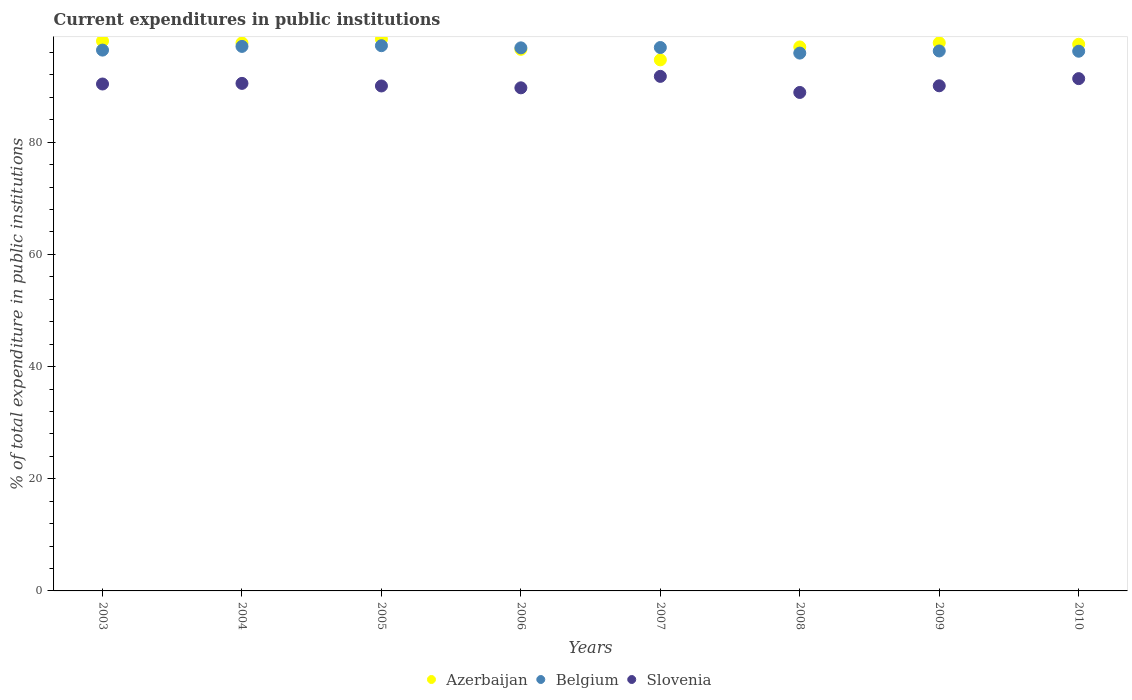Is the number of dotlines equal to the number of legend labels?
Keep it short and to the point. Yes. What is the current expenditures in public institutions in Belgium in 2006?
Provide a succinct answer. 96.82. Across all years, what is the maximum current expenditures in public institutions in Belgium?
Provide a short and direct response. 97.21. Across all years, what is the minimum current expenditures in public institutions in Azerbaijan?
Provide a succinct answer. 94.68. In which year was the current expenditures in public institutions in Azerbaijan maximum?
Offer a terse response. 2005. What is the total current expenditures in public institutions in Belgium in the graph?
Provide a short and direct response. 772.79. What is the difference between the current expenditures in public institutions in Azerbaijan in 2004 and that in 2009?
Make the answer very short. -0.02. What is the difference between the current expenditures in public institutions in Azerbaijan in 2003 and the current expenditures in public institutions in Belgium in 2008?
Your answer should be compact. 2.14. What is the average current expenditures in public institutions in Azerbaijan per year?
Provide a short and direct response. 97.19. In the year 2007, what is the difference between the current expenditures in public institutions in Slovenia and current expenditures in public institutions in Belgium?
Provide a short and direct response. -5.14. What is the ratio of the current expenditures in public institutions in Azerbaijan in 2006 to that in 2010?
Offer a terse response. 0.99. Is the current expenditures in public institutions in Belgium in 2009 less than that in 2010?
Ensure brevity in your answer.  No. Is the difference between the current expenditures in public institutions in Slovenia in 2003 and 2005 greater than the difference between the current expenditures in public institutions in Belgium in 2003 and 2005?
Provide a succinct answer. Yes. What is the difference between the highest and the second highest current expenditures in public institutions in Belgium?
Your answer should be very brief. 0.13. What is the difference between the highest and the lowest current expenditures in public institutions in Slovenia?
Give a very brief answer. 2.87. In how many years, is the current expenditures in public institutions in Belgium greater than the average current expenditures in public institutions in Belgium taken over all years?
Offer a very short reply. 4. Is it the case that in every year, the sum of the current expenditures in public institutions in Slovenia and current expenditures in public institutions in Belgium  is greater than the current expenditures in public institutions in Azerbaijan?
Offer a very short reply. Yes. Does the current expenditures in public institutions in Azerbaijan monotonically increase over the years?
Provide a short and direct response. No. Is the current expenditures in public institutions in Belgium strictly greater than the current expenditures in public institutions in Slovenia over the years?
Provide a short and direct response. Yes. What is the difference between two consecutive major ticks on the Y-axis?
Your answer should be compact. 20. Are the values on the major ticks of Y-axis written in scientific E-notation?
Your response must be concise. No. Where does the legend appear in the graph?
Make the answer very short. Bottom center. How are the legend labels stacked?
Ensure brevity in your answer.  Horizontal. What is the title of the graph?
Give a very brief answer. Current expenditures in public institutions. Does "Paraguay" appear as one of the legend labels in the graph?
Make the answer very short. No. What is the label or title of the Y-axis?
Your answer should be very brief. % of total expenditure in public institutions. What is the % of total expenditure in public institutions in Azerbaijan in 2003?
Give a very brief answer. 98.03. What is the % of total expenditure in public institutions of Belgium in 2003?
Offer a terse response. 96.42. What is the % of total expenditure in public institutions in Slovenia in 2003?
Your response must be concise. 90.38. What is the % of total expenditure in public institutions in Azerbaijan in 2004?
Offer a very short reply. 97.7. What is the % of total expenditure in public institutions of Belgium in 2004?
Provide a short and direct response. 97.08. What is the % of total expenditure in public institutions in Slovenia in 2004?
Ensure brevity in your answer.  90.49. What is the % of total expenditure in public institutions in Azerbaijan in 2005?
Offer a terse response. 98.36. What is the % of total expenditure in public institutions of Belgium in 2005?
Make the answer very short. 97.21. What is the % of total expenditure in public institutions of Slovenia in 2005?
Ensure brevity in your answer.  90.03. What is the % of total expenditure in public institutions in Azerbaijan in 2006?
Provide a short and direct response. 96.56. What is the % of total expenditure in public institutions of Belgium in 2006?
Your answer should be compact. 96.82. What is the % of total expenditure in public institutions of Slovenia in 2006?
Make the answer very short. 89.7. What is the % of total expenditure in public institutions of Azerbaijan in 2007?
Your answer should be compact. 94.68. What is the % of total expenditure in public institutions in Belgium in 2007?
Ensure brevity in your answer.  96.88. What is the % of total expenditure in public institutions of Slovenia in 2007?
Your answer should be very brief. 91.74. What is the % of total expenditure in public institutions in Azerbaijan in 2008?
Give a very brief answer. 96.99. What is the % of total expenditure in public institutions of Belgium in 2008?
Your answer should be very brief. 95.89. What is the % of total expenditure in public institutions of Slovenia in 2008?
Your answer should be compact. 88.87. What is the % of total expenditure in public institutions in Azerbaijan in 2009?
Your answer should be compact. 97.72. What is the % of total expenditure in public institutions in Belgium in 2009?
Give a very brief answer. 96.27. What is the % of total expenditure in public institutions in Slovenia in 2009?
Make the answer very short. 90.06. What is the % of total expenditure in public institutions of Azerbaijan in 2010?
Keep it short and to the point. 97.46. What is the % of total expenditure in public institutions of Belgium in 2010?
Offer a very short reply. 96.22. What is the % of total expenditure in public institutions of Slovenia in 2010?
Your answer should be very brief. 91.34. Across all years, what is the maximum % of total expenditure in public institutions in Azerbaijan?
Keep it short and to the point. 98.36. Across all years, what is the maximum % of total expenditure in public institutions of Belgium?
Offer a terse response. 97.21. Across all years, what is the maximum % of total expenditure in public institutions in Slovenia?
Offer a very short reply. 91.74. Across all years, what is the minimum % of total expenditure in public institutions of Azerbaijan?
Keep it short and to the point. 94.68. Across all years, what is the minimum % of total expenditure in public institutions of Belgium?
Offer a very short reply. 95.89. Across all years, what is the minimum % of total expenditure in public institutions in Slovenia?
Your answer should be compact. 88.87. What is the total % of total expenditure in public institutions of Azerbaijan in the graph?
Your response must be concise. 777.49. What is the total % of total expenditure in public institutions of Belgium in the graph?
Make the answer very short. 772.79. What is the total % of total expenditure in public institutions of Slovenia in the graph?
Offer a terse response. 722.6. What is the difference between the % of total expenditure in public institutions in Azerbaijan in 2003 and that in 2004?
Your answer should be very brief. 0.34. What is the difference between the % of total expenditure in public institutions of Belgium in 2003 and that in 2004?
Make the answer very short. -0.66. What is the difference between the % of total expenditure in public institutions of Slovenia in 2003 and that in 2004?
Ensure brevity in your answer.  -0.11. What is the difference between the % of total expenditure in public institutions in Azerbaijan in 2003 and that in 2005?
Ensure brevity in your answer.  -0.33. What is the difference between the % of total expenditure in public institutions of Belgium in 2003 and that in 2005?
Provide a short and direct response. -0.79. What is the difference between the % of total expenditure in public institutions of Slovenia in 2003 and that in 2005?
Ensure brevity in your answer.  0.35. What is the difference between the % of total expenditure in public institutions of Azerbaijan in 2003 and that in 2006?
Keep it short and to the point. 1.47. What is the difference between the % of total expenditure in public institutions of Belgium in 2003 and that in 2006?
Your answer should be very brief. -0.4. What is the difference between the % of total expenditure in public institutions of Slovenia in 2003 and that in 2006?
Ensure brevity in your answer.  0.68. What is the difference between the % of total expenditure in public institutions in Azerbaijan in 2003 and that in 2007?
Your response must be concise. 3.35. What is the difference between the % of total expenditure in public institutions of Belgium in 2003 and that in 2007?
Ensure brevity in your answer.  -0.46. What is the difference between the % of total expenditure in public institutions in Slovenia in 2003 and that in 2007?
Offer a terse response. -1.36. What is the difference between the % of total expenditure in public institutions of Azerbaijan in 2003 and that in 2008?
Offer a terse response. 1.05. What is the difference between the % of total expenditure in public institutions in Belgium in 2003 and that in 2008?
Your answer should be compact. 0.53. What is the difference between the % of total expenditure in public institutions of Slovenia in 2003 and that in 2008?
Your response must be concise. 1.51. What is the difference between the % of total expenditure in public institutions in Azerbaijan in 2003 and that in 2009?
Your answer should be very brief. 0.32. What is the difference between the % of total expenditure in public institutions in Belgium in 2003 and that in 2009?
Give a very brief answer. 0.15. What is the difference between the % of total expenditure in public institutions of Slovenia in 2003 and that in 2009?
Provide a short and direct response. 0.32. What is the difference between the % of total expenditure in public institutions of Azerbaijan in 2003 and that in 2010?
Provide a succinct answer. 0.57. What is the difference between the % of total expenditure in public institutions in Belgium in 2003 and that in 2010?
Your response must be concise. 0.2. What is the difference between the % of total expenditure in public institutions in Slovenia in 2003 and that in 2010?
Ensure brevity in your answer.  -0.96. What is the difference between the % of total expenditure in public institutions in Azerbaijan in 2004 and that in 2005?
Ensure brevity in your answer.  -0.66. What is the difference between the % of total expenditure in public institutions in Belgium in 2004 and that in 2005?
Make the answer very short. -0.13. What is the difference between the % of total expenditure in public institutions of Slovenia in 2004 and that in 2005?
Offer a very short reply. 0.46. What is the difference between the % of total expenditure in public institutions of Azerbaijan in 2004 and that in 2006?
Provide a short and direct response. 1.14. What is the difference between the % of total expenditure in public institutions in Belgium in 2004 and that in 2006?
Keep it short and to the point. 0.26. What is the difference between the % of total expenditure in public institutions in Slovenia in 2004 and that in 2006?
Ensure brevity in your answer.  0.79. What is the difference between the % of total expenditure in public institutions in Azerbaijan in 2004 and that in 2007?
Provide a succinct answer. 3.02. What is the difference between the % of total expenditure in public institutions in Belgium in 2004 and that in 2007?
Your response must be concise. 0.2. What is the difference between the % of total expenditure in public institutions of Slovenia in 2004 and that in 2007?
Make the answer very short. -1.25. What is the difference between the % of total expenditure in public institutions of Azerbaijan in 2004 and that in 2008?
Keep it short and to the point. 0.71. What is the difference between the % of total expenditure in public institutions of Belgium in 2004 and that in 2008?
Your response must be concise. 1.19. What is the difference between the % of total expenditure in public institutions in Slovenia in 2004 and that in 2008?
Make the answer very short. 1.62. What is the difference between the % of total expenditure in public institutions of Azerbaijan in 2004 and that in 2009?
Give a very brief answer. -0.02. What is the difference between the % of total expenditure in public institutions of Belgium in 2004 and that in 2009?
Offer a very short reply. 0.81. What is the difference between the % of total expenditure in public institutions of Slovenia in 2004 and that in 2009?
Make the answer very short. 0.43. What is the difference between the % of total expenditure in public institutions of Azerbaijan in 2004 and that in 2010?
Offer a terse response. 0.23. What is the difference between the % of total expenditure in public institutions in Belgium in 2004 and that in 2010?
Keep it short and to the point. 0.86. What is the difference between the % of total expenditure in public institutions in Slovenia in 2004 and that in 2010?
Keep it short and to the point. -0.85. What is the difference between the % of total expenditure in public institutions in Azerbaijan in 2005 and that in 2006?
Offer a terse response. 1.8. What is the difference between the % of total expenditure in public institutions in Belgium in 2005 and that in 2006?
Ensure brevity in your answer.  0.39. What is the difference between the % of total expenditure in public institutions of Slovenia in 2005 and that in 2006?
Provide a succinct answer. 0.33. What is the difference between the % of total expenditure in public institutions in Azerbaijan in 2005 and that in 2007?
Offer a terse response. 3.68. What is the difference between the % of total expenditure in public institutions in Belgium in 2005 and that in 2007?
Your response must be concise. 0.33. What is the difference between the % of total expenditure in public institutions in Slovenia in 2005 and that in 2007?
Ensure brevity in your answer.  -1.71. What is the difference between the % of total expenditure in public institutions in Azerbaijan in 2005 and that in 2008?
Provide a short and direct response. 1.37. What is the difference between the % of total expenditure in public institutions in Belgium in 2005 and that in 2008?
Offer a very short reply. 1.32. What is the difference between the % of total expenditure in public institutions in Slovenia in 2005 and that in 2008?
Ensure brevity in your answer.  1.16. What is the difference between the % of total expenditure in public institutions of Azerbaijan in 2005 and that in 2009?
Your answer should be very brief. 0.64. What is the difference between the % of total expenditure in public institutions of Belgium in 2005 and that in 2009?
Offer a very short reply. 0.94. What is the difference between the % of total expenditure in public institutions in Slovenia in 2005 and that in 2009?
Your answer should be compact. -0.03. What is the difference between the % of total expenditure in public institutions in Azerbaijan in 2005 and that in 2010?
Give a very brief answer. 0.9. What is the difference between the % of total expenditure in public institutions of Belgium in 2005 and that in 2010?
Offer a very short reply. 0.98. What is the difference between the % of total expenditure in public institutions of Slovenia in 2005 and that in 2010?
Give a very brief answer. -1.31. What is the difference between the % of total expenditure in public institutions in Azerbaijan in 2006 and that in 2007?
Your response must be concise. 1.88. What is the difference between the % of total expenditure in public institutions in Belgium in 2006 and that in 2007?
Give a very brief answer. -0.06. What is the difference between the % of total expenditure in public institutions of Slovenia in 2006 and that in 2007?
Provide a succinct answer. -2.04. What is the difference between the % of total expenditure in public institutions in Azerbaijan in 2006 and that in 2008?
Offer a terse response. -0.43. What is the difference between the % of total expenditure in public institutions in Belgium in 2006 and that in 2008?
Keep it short and to the point. 0.93. What is the difference between the % of total expenditure in public institutions in Slovenia in 2006 and that in 2008?
Give a very brief answer. 0.83. What is the difference between the % of total expenditure in public institutions of Azerbaijan in 2006 and that in 2009?
Provide a succinct answer. -1.16. What is the difference between the % of total expenditure in public institutions in Belgium in 2006 and that in 2009?
Provide a succinct answer. 0.55. What is the difference between the % of total expenditure in public institutions in Slovenia in 2006 and that in 2009?
Your answer should be very brief. -0.36. What is the difference between the % of total expenditure in public institutions in Azerbaijan in 2006 and that in 2010?
Your response must be concise. -0.9. What is the difference between the % of total expenditure in public institutions in Belgium in 2006 and that in 2010?
Your answer should be very brief. 0.6. What is the difference between the % of total expenditure in public institutions of Slovenia in 2006 and that in 2010?
Provide a succinct answer. -1.64. What is the difference between the % of total expenditure in public institutions of Azerbaijan in 2007 and that in 2008?
Your response must be concise. -2.31. What is the difference between the % of total expenditure in public institutions in Slovenia in 2007 and that in 2008?
Make the answer very short. 2.87. What is the difference between the % of total expenditure in public institutions of Azerbaijan in 2007 and that in 2009?
Keep it short and to the point. -3.04. What is the difference between the % of total expenditure in public institutions in Belgium in 2007 and that in 2009?
Keep it short and to the point. 0.61. What is the difference between the % of total expenditure in public institutions of Slovenia in 2007 and that in 2009?
Offer a terse response. 1.68. What is the difference between the % of total expenditure in public institutions of Azerbaijan in 2007 and that in 2010?
Make the answer very short. -2.78. What is the difference between the % of total expenditure in public institutions in Belgium in 2007 and that in 2010?
Offer a very short reply. 0.66. What is the difference between the % of total expenditure in public institutions in Slovenia in 2007 and that in 2010?
Provide a succinct answer. 0.4. What is the difference between the % of total expenditure in public institutions of Azerbaijan in 2008 and that in 2009?
Give a very brief answer. -0.73. What is the difference between the % of total expenditure in public institutions of Belgium in 2008 and that in 2009?
Offer a terse response. -0.38. What is the difference between the % of total expenditure in public institutions of Slovenia in 2008 and that in 2009?
Offer a terse response. -1.19. What is the difference between the % of total expenditure in public institutions in Azerbaijan in 2008 and that in 2010?
Your answer should be very brief. -0.48. What is the difference between the % of total expenditure in public institutions in Belgium in 2008 and that in 2010?
Provide a short and direct response. -0.33. What is the difference between the % of total expenditure in public institutions in Slovenia in 2008 and that in 2010?
Give a very brief answer. -2.46. What is the difference between the % of total expenditure in public institutions of Azerbaijan in 2009 and that in 2010?
Your answer should be compact. 0.25. What is the difference between the % of total expenditure in public institutions in Belgium in 2009 and that in 2010?
Your answer should be compact. 0.04. What is the difference between the % of total expenditure in public institutions in Slovenia in 2009 and that in 2010?
Offer a very short reply. -1.28. What is the difference between the % of total expenditure in public institutions of Azerbaijan in 2003 and the % of total expenditure in public institutions of Belgium in 2004?
Keep it short and to the point. 0.95. What is the difference between the % of total expenditure in public institutions in Azerbaijan in 2003 and the % of total expenditure in public institutions in Slovenia in 2004?
Offer a very short reply. 7.54. What is the difference between the % of total expenditure in public institutions of Belgium in 2003 and the % of total expenditure in public institutions of Slovenia in 2004?
Offer a terse response. 5.93. What is the difference between the % of total expenditure in public institutions of Azerbaijan in 2003 and the % of total expenditure in public institutions of Belgium in 2005?
Your response must be concise. 0.83. What is the difference between the % of total expenditure in public institutions in Azerbaijan in 2003 and the % of total expenditure in public institutions in Slovenia in 2005?
Your answer should be compact. 8.01. What is the difference between the % of total expenditure in public institutions of Belgium in 2003 and the % of total expenditure in public institutions of Slovenia in 2005?
Offer a terse response. 6.39. What is the difference between the % of total expenditure in public institutions in Azerbaijan in 2003 and the % of total expenditure in public institutions in Belgium in 2006?
Make the answer very short. 1.21. What is the difference between the % of total expenditure in public institutions in Azerbaijan in 2003 and the % of total expenditure in public institutions in Slovenia in 2006?
Offer a terse response. 8.34. What is the difference between the % of total expenditure in public institutions in Belgium in 2003 and the % of total expenditure in public institutions in Slovenia in 2006?
Provide a succinct answer. 6.72. What is the difference between the % of total expenditure in public institutions of Azerbaijan in 2003 and the % of total expenditure in public institutions of Belgium in 2007?
Keep it short and to the point. 1.15. What is the difference between the % of total expenditure in public institutions in Azerbaijan in 2003 and the % of total expenditure in public institutions in Slovenia in 2007?
Your answer should be very brief. 6.29. What is the difference between the % of total expenditure in public institutions of Belgium in 2003 and the % of total expenditure in public institutions of Slovenia in 2007?
Your answer should be very brief. 4.68. What is the difference between the % of total expenditure in public institutions in Azerbaijan in 2003 and the % of total expenditure in public institutions in Belgium in 2008?
Offer a terse response. 2.14. What is the difference between the % of total expenditure in public institutions in Azerbaijan in 2003 and the % of total expenditure in public institutions in Slovenia in 2008?
Give a very brief answer. 9.16. What is the difference between the % of total expenditure in public institutions of Belgium in 2003 and the % of total expenditure in public institutions of Slovenia in 2008?
Offer a very short reply. 7.55. What is the difference between the % of total expenditure in public institutions of Azerbaijan in 2003 and the % of total expenditure in public institutions of Belgium in 2009?
Your answer should be compact. 1.77. What is the difference between the % of total expenditure in public institutions of Azerbaijan in 2003 and the % of total expenditure in public institutions of Slovenia in 2009?
Provide a short and direct response. 7.97. What is the difference between the % of total expenditure in public institutions in Belgium in 2003 and the % of total expenditure in public institutions in Slovenia in 2009?
Ensure brevity in your answer.  6.36. What is the difference between the % of total expenditure in public institutions of Azerbaijan in 2003 and the % of total expenditure in public institutions of Belgium in 2010?
Provide a short and direct response. 1.81. What is the difference between the % of total expenditure in public institutions in Azerbaijan in 2003 and the % of total expenditure in public institutions in Slovenia in 2010?
Your answer should be compact. 6.7. What is the difference between the % of total expenditure in public institutions in Belgium in 2003 and the % of total expenditure in public institutions in Slovenia in 2010?
Your answer should be compact. 5.09. What is the difference between the % of total expenditure in public institutions in Azerbaijan in 2004 and the % of total expenditure in public institutions in Belgium in 2005?
Your response must be concise. 0.49. What is the difference between the % of total expenditure in public institutions of Azerbaijan in 2004 and the % of total expenditure in public institutions of Slovenia in 2005?
Provide a succinct answer. 7.67. What is the difference between the % of total expenditure in public institutions in Belgium in 2004 and the % of total expenditure in public institutions in Slovenia in 2005?
Keep it short and to the point. 7.05. What is the difference between the % of total expenditure in public institutions of Azerbaijan in 2004 and the % of total expenditure in public institutions of Belgium in 2006?
Provide a succinct answer. 0.87. What is the difference between the % of total expenditure in public institutions of Azerbaijan in 2004 and the % of total expenditure in public institutions of Slovenia in 2006?
Your answer should be compact. 8. What is the difference between the % of total expenditure in public institutions of Belgium in 2004 and the % of total expenditure in public institutions of Slovenia in 2006?
Offer a terse response. 7.38. What is the difference between the % of total expenditure in public institutions in Azerbaijan in 2004 and the % of total expenditure in public institutions in Belgium in 2007?
Make the answer very short. 0.81. What is the difference between the % of total expenditure in public institutions of Azerbaijan in 2004 and the % of total expenditure in public institutions of Slovenia in 2007?
Offer a terse response. 5.96. What is the difference between the % of total expenditure in public institutions in Belgium in 2004 and the % of total expenditure in public institutions in Slovenia in 2007?
Make the answer very short. 5.34. What is the difference between the % of total expenditure in public institutions in Azerbaijan in 2004 and the % of total expenditure in public institutions in Belgium in 2008?
Your answer should be very brief. 1.81. What is the difference between the % of total expenditure in public institutions in Azerbaijan in 2004 and the % of total expenditure in public institutions in Slovenia in 2008?
Your answer should be very brief. 8.82. What is the difference between the % of total expenditure in public institutions of Belgium in 2004 and the % of total expenditure in public institutions of Slovenia in 2008?
Ensure brevity in your answer.  8.21. What is the difference between the % of total expenditure in public institutions in Azerbaijan in 2004 and the % of total expenditure in public institutions in Belgium in 2009?
Offer a terse response. 1.43. What is the difference between the % of total expenditure in public institutions in Azerbaijan in 2004 and the % of total expenditure in public institutions in Slovenia in 2009?
Give a very brief answer. 7.64. What is the difference between the % of total expenditure in public institutions of Belgium in 2004 and the % of total expenditure in public institutions of Slovenia in 2009?
Your answer should be very brief. 7.02. What is the difference between the % of total expenditure in public institutions of Azerbaijan in 2004 and the % of total expenditure in public institutions of Belgium in 2010?
Make the answer very short. 1.47. What is the difference between the % of total expenditure in public institutions in Azerbaijan in 2004 and the % of total expenditure in public institutions in Slovenia in 2010?
Make the answer very short. 6.36. What is the difference between the % of total expenditure in public institutions in Belgium in 2004 and the % of total expenditure in public institutions in Slovenia in 2010?
Ensure brevity in your answer.  5.74. What is the difference between the % of total expenditure in public institutions of Azerbaijan in 2005 and the % of total expenditure in public institutions of Belgium in 2006?
Your answer should be compact. 1.54. What is the difference between the % of total expenditure in public institutions in Azerbaijan in 2005 and the % of total expenditure in public institutions in Slovenia in 2006?
Your answer should be very brief. 8.66. What is the difference between the % of total expenditure in public institutions of Belgium in 2005 and the % of total expenditure in public institutions of Slovenia in 2006?
Your response must be concise. 7.51. What is the difference between the % of total expenditure in public institutions of Azerbaijan in 2005 and the % of total expenditure in public institutions of Belgium in 2007?
Your answer should be very brief. 1.48. What is the difference between the % of total expenditure in public institutions of Azerbaijan in 2005 and the % of total expenditure in public institutions of Slovenia in 2007?
Make the answer very short. 6.62. What is the difference between the % of total expenditure in public institutions of Belgium in 2005 and the % of total expenditure in public institutions of Slovenia in 2007?
Ensure brevity in your answer.  5.47. What is the difference between the % of total expenditure in public institutions of Azerbaijan in 2005 and the % of total expenditure in public institutions of Belgium in 2008?
Offer a terse response. 2.47. What is the difference between the % of total expenditure in public institutions in Azerbaijan in 2005 and the % of total expenditure in public institutions in Slovenia in 2008?
Your answer should be compact. 9.49. What is the difference between the % of total expenditure in public institutions of Belgium in 2005 and the % of total expenditure in public institutions of Slovenia in 2008?
Offer a terse response. 8.34. What is the difference between the % of total expenditure in public institutions of Azerbaijan in 2005 and the % of total expenditure in public institutions of Belgium in 2009?
Give a very brief answer. 2.09. What is the difference between the % of total expenditure in public institutions of Azerbaijan in 2005 and the % of total expenditure in public institutions of Slovenia in 2009?
Offer a terse response. 8.3. What is the difference between the % of total expenditure in public institutions in Belgium in 2005 and the % of total expenditure in public institutions in Slovenia in 2009?
Your answer should be very brief. 7.15. What is the difference between the % of total expenditure in public institutions in Azerbaijan in 2005 and the % of total expenditure in public institutions in Belgium in 2010?
Provide a succinct answer. 2.14. What is the difference between the % of total expenditure in public institutions in Azerbaijan in 2005 and the % of total expenditure in public institutions in Slovenia in 2010?
Provide a succinct answer. 7.02. What is the difference between the % of total expenditure in public institutions of Belgium in 2005 and the % of total expenditure in public institutions of Slovenia in 2010?
Your answer should be very brief. 5.87. What is the difference between the % of total expenditure in public institutions in Azerbaijan in 2006 and the % of total expenditure in public institutions in Belgium in 2007?
Provide a short and direct response. -0.32. What is the difference between the % of total expenditure in public institutions of Azerbaijan in 2006 and the % of total expenditure in public institutions of Slovenia in 2007?
Ensure brevity in your answer.  4.82. What is the difference between the % of total expenditure in public institutions of Belgium in 2006 and the % of total expenditure in public institutions of Slovenia in 2007?
Your response must be concise. 5.08. What is the difference between the % of total expenditure in public institutions in Azerbaijan in 2006 and the % of total expenditure in public institutions in Belgium in 2008?
Provide a succinct answer. 0.67. What is the difference between the % of total expenditure in public institutions of Azerbaijan in 2006 and the % of total expenditure in public institutions of Slovenia in 2008?
Provide a succinct answer. 7.69. What is the difference between the % of total expenditure in public institutions of Belgium in 2006 and the % of total expenditure in public institutions of Slovenia in 2008?
Give a very brief answer. 7.95. What is the difference between the % of total expenditure in public institutions in Azerbaijan in 2006 and the % of total expenditure in public institutions in Belgium in 2009?
Provide a succinct answer. 0.29. What is the difference between the % of total expenditure in public institutions in Azerbaijan in 2006 and the % of total expenditure in public institutions in Slovenia in 2009?
Give a very brief answer. 6.5. What is the difference between the % of total expenditure in public institutions in Belgium in 2006 and the % of total expenditure in public institutions in Slovenia in 2009?
Your answer should be compact. 6.76. What is the difference between the % of total expenditure in public institutions in Azerbaijan in 2006 and the % of total expenditure in public institutions in Belgium in 2010?
Provide a succinct answer. 0.34. What is the difference between the % of total expenditure in public institutions of Azerbaijan in 2006 and the % of total expenditure in public institutions of Slovenia in 2010?
Make the answer very short. 5.22. What is the difference between the % of total expenditure in public institutions of Belgium in 2006 and the % of total expenditure in public institutions of Slovenia in 2010?
Ensure brevity in your answer.  5.49. What is the difference between the % of total expenditure in public institutions in Azerbaijan in 2007 and the % of total expenditure in public institutions in Belgium in 2008?
Your answer should be compact. -1.21. What is the difference between the % of total expenditure in public institutions in Azerbaijan in 2007 and the % of total expenditure in public institutions in Slovenia in 2008?
Keep it short and to the point. 5.81. What is the difference between the % of total expenditure in public institutions in Belgium in 2007 and the % of total expenditure in public institutions in Slovenia in 2008?
Make the answer very short. 8.01. What is the difference between the % of total expenditure in public institutions of Azerbaijan in 2007 and the % of total expenditure in public institutions of Belgium in 2009?
Offer a very short reply. -1.59. What is the difference between the % of total expenditure in public institutions in Azerbaijan in 2007 and the % of total expenditure in public institutions in Slovenia in 2009?
Keep it short and to the point. 4.62. What is the difference between the % of total expenditure in public institutions in Belgium in 2007 and the % of total expenditure in public institutions in Slovenia in 2009?
Make the answer very short. 6.82. What is the difference between the % of total expenditure in public institutions of Azerbaijan in 2007 and the % of total expenditure in public institutions of Belgium in 2010?
Your response must be concise. -1.54. What is the difference between the % of total expenditure in public institutions in Azerbaijan in 2007 and the % of total expenditure in public institutions in Slovenia in 2010?
Keep it short and to the point. 3.34. What is the difference between the % of total expenditure in public institutions in Belgium in 2007 and the % of total expenditure in public institutions in Slovenia in 2010?
Provide a short and direct response. 5.55. What is the difference between the % of total expenditure in public institutions in Azerbaijan in 2008 and the % of total expenditure in public institutions in Belgium in 2009?
Your response must be concise. 0.72. What is the difference between the % of total expenditure in public institutions in Azerbaijan in 2008 and the % of total expenditure in public institutions in Slovenia in 2009?
Provide a short and direct response. 6.93. What is the difference between the % of total expenditure in public institutions in Belgium in 2008 and the % of total expenditure in public institutions in Slovenia in 2009?
Make the answer very short. 5.83. What is the difference between the % of total expenditure in public institutions of Azerbaijan in 2008 and the % of total expenditure in public institutions of Belgium in 2010?
Make the answer very short. 0.76. What is the difference between the % of total expenditure in public institutions of Azerbaijan in 2008 and the % of total expenditure in public institutions of Slovenia in 2010?
Give a very brief answer. 5.65. What is the difference between the % of total expenditure in public institutions of Belgium in 2008 and the % of total expenditure in public institutions of Slovenia in 2010?
Make the answer very short. 4.55. What is the difference between the % of total expenditure in public institutions in Azerbaijan in 2009 and the % of total expenditure in public institutions in Belgium in 2010?
Provide a short and direct response. 1.49. What is the difference between the % of total expenditure in public institutions in Azerbaijan in 2009 and the % of total expenditure in public institutions in Slovenia in 2010?
Offer a very short reply. 6.38. What is the difference between the % of total expenditure in public institutions of Belgium in 2009 and the % of total expenditure in public institutions of Slovenia in 2010?
Provide a short and direct response. 4.93. What is the average % of total expenditure in public institutions of Azerbaijan per year?
Your answer should be compact. 97.19. What is the average % of total expenditure in public institutions of Belgium per year?
Ensure brevity in your answer.  96.6. What is the average % of total expenditure in public institutions of Slovenia per year?
Provide a succinct answer. 90.32. In the year 2003, what is the difference between the % of total expenditure in public institutions of Azerbaijan and % of total expenditure in public institutions of Belgium?
Ensure brevity in your answer.  1.61. In the year 2003, what is the difference between the % of total expenditure in public institutions in Azerbaijan and % of total expenditure in public institutions in Slovenia?
Your response must be concise. 7.65. In the year 2003, what is the difference between the % of total expenditure in public institutions in Belgium and % of total expenditure in public institutions in Slovenia?
Provide a short and direct response. 6.04. In the year 2004, what is the difference between the % of total expenditure in public institutions in Azerbaijan and % of total expenditure in public institutions in Belgium?
Give a very brief answer. 0.61. In the year 2004, what is the difference between the % of total expenditure in public institutions of Azerbaijan and % of total expenditure in public institutions of Slovenia?
Make the answer very short. 7.21. In the year 2004, what is the difference between the % of total expenditure in public institutions of Belgium and % of total expenditure in public institutions of Slovenia?
Provide a succinct answer. 6.59. In the year 2005, what is the difference between the % of total expenditure in public institutions of Azerbaijan and % of total expenditure in public institutions of Belgium?
Your answer should be very brief. 1.15. In the year 2005, what is the difference between the % of total expenditure in public institutions in Azerbaijan and % of total expenditure in public institutions in Slovenia?
Provide a short and direct response. 8.33. In the year 2005, what is the difference between the % of total expenditure in public institutions in Belgium and % of total expenditure in public institutions in Slovenia?
Provide a short and direct response. 7.18. In the year 2006, what is the difference between the % of total expenditure in public institutions of Azerbaijan and % of total expenditure in public institutions of Belgium?
Your answer should be compact. -0.26. In the year 2006, what is the difference between the % of total expenditure in public institutions of Azerbaijan and % of total expenditure in public institutions of Slovenia?
Your answer should be very brief. 6.86. In the year 2006, what is the difference between the % of total expenditure in public institutions of Belgium and % of total expenditure in public institutions of Slovenia?
Your response must be concise. 7.13. In the year 2007, what is the difference between the % of total expenditure in public institutions in Azerbaijan and % of total expenditure in public institutions in Belgium?
Your answer should be compact. -2.2. In the year 2007, what is the difference between the % of total expenditure in public institutions of Azerbaijan and % of total expenditure in public institutions of Slovenia?
Offer a very short reply. 2.94. In the year 2007, what is the difference between the % of total expenditure in public institutions in Belgium and % of total expenditure in public institutions in Slovenia?
Keep it short and to the point. 5.14. In the year 2008, what is the difference between the % of total expenditure in public institutions in Azerbaijan and % of total expenditure in public institutions in Belgium?
Your answer should be very brief. 1.1. In the year 2008, what is the difference between the % of total expenditure in public institutions of Azerbaijan and % of total expenditure in public institutions of Slovenia?
Offer a terse response. 8.11. In the year 2008, what is the difference between the % of total expenditure in public institutions in Belgium and % of total expenditure in public institutions in Slovenia?
Your answer should be compact. 7.02. In the year 2009, what is the difference between the % of total expenditure in public institutions of Azerbaijan and % of total expenditure in public institutions of Belgium?
Your response must be concise. 1.45. In the year 2009, what is the difference between the % of total expenditure in public institutions in Azerbaijan and % of total expenditure in public institutions in Slovenia?
Give a very brief answer. 7.66. In the year 2009, what is the difference between the % of total expenditure in public institutions of Belgium and % of total expenditure in public institutions of Slovenia?
Keep it short and to the point. 6.21. In the year 2010, what is the difference between the % of total expenditure in public institutions of Azerbaijan and % of total expenditure in public institutions of Belgium?
Give a very brief answer. 1.24. In the year 2010, what is the difference between the % of total expenditure in public institutions in Azerbaijan and % of total expenditure in public institutions in Slovenia?
Provide a short and direct response. 6.13. In the year 2010, what is the difference between the % of total expenditure in public institutions of Belgium and % of total expenditure in public institutions of Slovenia?
Your answer should be compact. 4.89. What is the ratio of the % of total expenditure in public institutions of Belgium in 2003 to that in 2004?
Your response must be concise. 0.99. What is the ratio of the % of total expenditure in public institutions in Azerbaijan in 2003 to that in 2006?
Provide a succinct answer. 1.02. What is the ratio of the % of total expenditure in public institutions of Slovenia in 2003 to that in 2006?
Your response must be concise. 1.01. What is the ratio of the % of total expenditure in public institutions of Azerbaijan in 2003 to that in 2007?
Provide a succinct answer. 1.04. What is the ratio of the % of total expenditure in public institutions in Belgium in 2003 to that in 2007?
Make the answer very short. 1. What is the ratio of the % of total expenditure in public institutions of Slovenia in 2003 to that in 2007?
Your answer should be very brief. 0.99. What is the ratio of the % of total expenditure in public institutions in Azerbaijan in 2003 to that in 2008?
Offer a very short reply. 1.01. What is the ratio of the % of total expenditure in public institutions of Belgium in 2003 to that in 2008?
Ensure brevity in your answer.  1.01. What is the ratio of the % of total expenditure in public institutions in Azerbaijan in 2003 to that in 2009?
Provide a succinct answer. 1. What is the ratio of the % of total expenditure in public institutions of Azerbaijan in 2003 to that in 2010?
Offer a very short reply. 1.01. What is the ratio of the % of total expenditure in public institutions of Azerbaijan in 2004 to that in 2006?
Ensure brevity in your answer.  1.01. What is the ratio of the % of total expenditure in public institutions in Belgium in 2004 to that in 2006?
Your answer should be compact. 1. What is the ratio of the % of total expenditure in public institutions in Slovenia in 2004 to that in 2006?
Provide a short and direct response. 1.01. What is the ratio of the % of total expenditure in public institutions in Azerbaijan in 2004 to that in 2007?
Your answer should be compact. 1.03. What is the ratio of the % of total expenditure in public institutions of Slovenia in 2004 to that in 2007?
Keep it short and to the point. 0.99. What is the ratio of the % of total expenditure in public institutions of Azerbaijan in 2004 to that in 2008?
Give a very brief answer. 1.01. What is the ratio of the % of total expenditure in public institutions of Belgium in 2004 to that in 2008?
Keep it short and to the point. 1.01. What is the ratio of the % of total expenditure in public institutions of Slovenia in 2004 to that in 2008?
Provide a succinct answer. 1.02. What is the ratio of the % of total expenditure in public institutions of Azerbaijan in 2004 to that in 2009?
Give a very brief answer. 1. What is the ratio of the % of total expenditure in public institutions of Belgium in 2004 to that in 2009?
Keep it short and to the point. 1.01. What is the ratio of the % of total expenditure in public institutions in Azerbaijan in 2004 to that in 2010?
Offer a very short reply. 1. What is the ratio of the % of total expenditure in public institutions of Belgium in 2004 to that in 2010?
Make the answer very short. 1.01. What is the ratio of the % of total expenditure in public institutions in Slovenia in 2004 to that in 2010?
Offer a terse response. 0.99. What is the ratio of the % of total expenditure in public institutions of Azerbaijan in 2005 to that in 2006?
Your answer should be very brief. 1.02. What is the ratio of the % of total expenditure in public institutions in Belgium in 2005 to that in 2006?
Keep it short and to the point. 1. What is the ratio of the % of total expenditure in public institutions in Azerbaijan in 2005 to that in 2007?
Offer a terse response. 1.04. What is the ratio of the % of total expenditure in public institutions in Slovenia in 2005 to that in 2007?
Your response must be concise. 0.98. What is the ratio of the % of total expenditure in public institutions in Azerbaijan in 2005 to that in 2008?
Your answer should be compact. 1.01. What is the ratio of the % of total expenditure in public institutions of Belgium in 2005 to that in 2008?
Your answer should be very brief. 1.01. What is the ratio of the % of total expenditure in public institutions of Azerbaijan in 2005 to that in 2009?
Make the answer very short. 1.01. What is the ratio of the % of total expenditure in public institutions of Belgium in 2005 to that in 2009?
Ensure brevity in your answer.  1.01. What is the ratio of the % of total expenditure in public institutions of Slovenia in 2005 to that in 2009?
Provide a short and direct response. 1. What is the ratio of the % of total expenditure in public institutions of Azerbaijan in 2005 to that in 2010?
Provide a short and direct response. 1.01. What is the ratio of the % of total expenditure in public institutions in Belgium in 2005 to that in 2010?
Ensure brevity in your answer.  1.01. What is the ratio of the % of total expenditure in public institutions in Slovenia in 2005 to that in 2010?
Ensure brevity in your answer.  0.99. What is the ratio of the % of total expenditure in public institutions in Azerbaijan in 2006 to that in 2007?
Provide a succinct answer. 1.02. What is the ratio of the % of total expenditure in public institutions in Belgium in 2006 to that in 2007?
Offer a terse response. 1. What is the ratio of the % of total expenditure in public institutions in Slovenia in 2006 to that in 2007?
Keep it short and to the point. 0.98. What is the ratio of the % of total expenditure in public institutions of Belgium in 2006 to that in 2008?
Keep it short and to the point. 1.01. What is the ratio of the % of total expenditure in public institutions of Slovenia in 2006 to that in 2008?
Provide a short and direct response. 1.01. What is the ratio of the % of total expenditure in public institutions in Azerbaijan in 2006 to that in 2009?
Give a very brief answer. 0.99. What is the ratio of the % of total expenditure in public institutions in Slovenia in 2006 to that in 2009?
Your answer should be compact. 1. What is the ratio of the % of total expenditure in public institutions in Azerbaijan in 2006 to that in 2010?
Provide a short and direct response. 0.99. What is the ratio of the % of total expenditure in public institutions in Belgium in 2006 to that in 2010?
Provide a succinct answer. 1.01. What is the ratio of the % of total expenditure in public institutions in Slovenia in 2006 to that in 2010?
Offer a very short reply. 0.98. What is the ratio of the % of total expenditure in public institutions in Azerbaijan in 2007 to that in 2008?
Your response must be concise. 0.98. What is the ratio of the % of total expenditure in public institutions of Belgium in 2007 to that in 2008?
Provide a succinct answer. 1.01. What is the ratio of the % of total expenditure in public institutions in Slovenia in 2007 to that in 2008?
Your answer should be compact. 1.03. What is the ratio of the % of total expenditure in public institutions of Azerbaijan in 2007 to that in 2009?
Provide a succinct answer. 0.97. What is the ratio of the % of total expenditure in public institutions in Belgium in 2007 to that in 2009?
Provide a short and direct response. 1.01. What is the ratio of the % of total expenditure in public institutions of Slovenia in 2007 to that in 2009?
Make the answer very short. 1.02. What is the ratio of the % of total expenditure in public institutions in Azerbaijan in 2007 to that in 2010?
Offer a terse response. 0.97. What is the ratio of the % of total expenditure in public institutions in Belgium in 2007 to that in 2010?
Keep it short and to the point. 1.01. What is the ratio of the % of total expenditure in public institutions in Slovenia in 2007 to that in 2010?
Provide a succinct answer. 1. What is the ratio of the % of total expenditure in public institutions in Azerbaijan in 2008 to that in 2010?
Keep it short and to the point. 1. What is the ratio of the % of total expenditure in public institutions of Slovenia in 2008 to that in 2010?
Offer a terse response. 0.97. What is the ratio of the % of total expenditure in public institutions in Belgium in 2009 to that in 2010?
Ensure brevity in your answer.  1. What is the ratio of the % of total expenditure in public institutions in Slovenia in 2009 to that in 2010?
Your response must be concise. 0.99. What is the difference between the highest and the second highest % of total expenditure in public institutions in Azerbaijan?
Give a very brief answer. 0.33. What is the difference between the highest and the second highest % of total expenditure in public institutions in Belgium?
Offer a terse response. 0.13. What is the difference between the highest and the second highest % of total expenditure in public institutions of Slovenia?
Provide a succinct answer. 0.4. What is the difference between the highest and the lowest % of total expenditure in public institutions in Azerbaijan?
Your response must be concise. 3.68. What is the difference between the highest and the lowest % of total expenditure in public institutions of Belgium?
Give a very brief answer. 1.32. What is the difference between the highest and the lowest % of total expenditure in public institutions of Slovenia?
Offer a terse response. 2.87. 